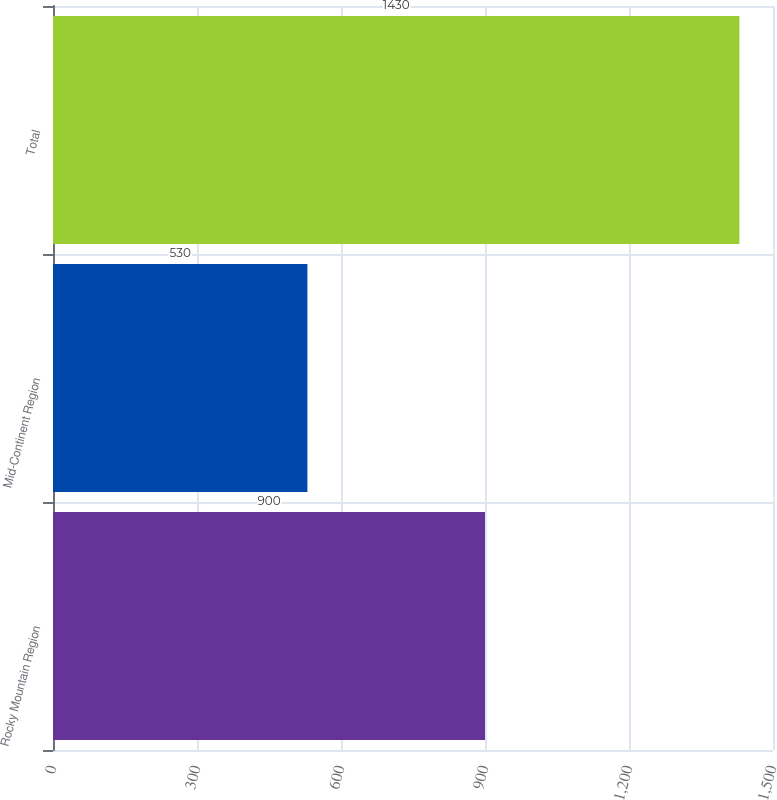Convert chart. <chart><loc_0><loc_0><loc_500><loc_500><bar_chart><fcel>Rocky Mountain Region<fcel>Mid-Continent Region<fcel>Total<nl><fcel>900<fcel>530<fcel>1430<nl></chart> 